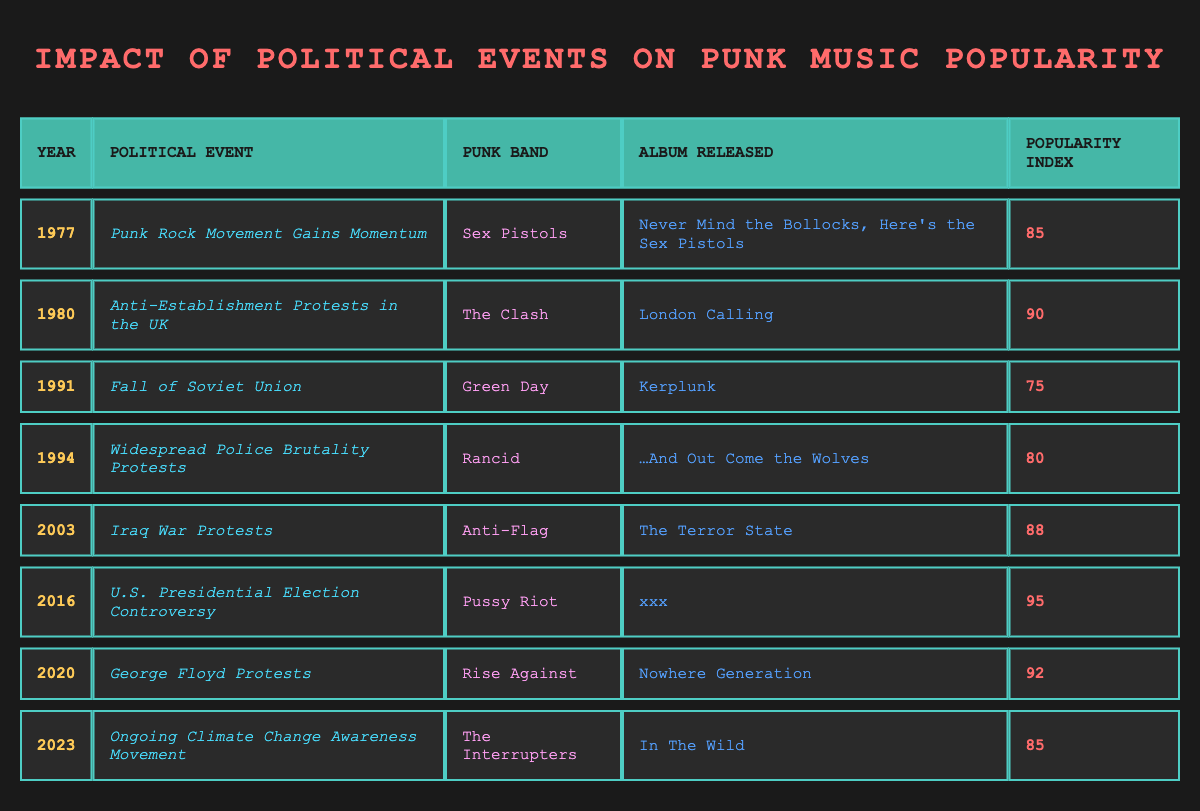What was the popularity index of The Clash's album released in 1980? The Clash released their album "London Calling" in 1980, which has a popularity index of 90 according to the table.
Answer: 90 Which punk band had the highest popularity index and in what year did they release their album? The punk band with the highest popularity index is Pussy Riot, who released the album "xxx" in 2016 with a popularity index of 95.
Answer: Pussy Riot, 2016 Between which years did the popularity index increase from one album to the next? From 2003 to 2016, the popularity index increased from 88 (Anti-Flag’s "The Terror State") to 95 (Pussy Riot’s "xxx"). This indicates a rise over those years.
Answer: 2003 to 2016 Was there any year where the popularity index fell below 80? Yes, the year 1991 shows a popularity index of 75, which is below 80.
Answer: Yes What is the average popularity index of the punk bands between the years 1990 and 2020? The popularity indices for the given years are 75 (1991) + 80 (1994) + 88 (2003) + 95 (2016) + 92 (2020) = 430. There are 5 data points; 430 / 5 = 86.
Answer: 86 Which political event occurred in 1994? The political event that occurred in 1994 was "Widespread Police Brutality Protests," which coincided with Rancid's album release of "…And Out Come the Wolves."
Answer: Widespread Police Brutality Protests How many punk bands released albums that had a popularity index of 85 or higher from 2000 to 2023? From 2000 to 2023, three punk bands released albums with a popularity index of 85 or higher: Anti-Flag (2003, 88), Pussy Riot (2016, 95), and Rise Against (2020, 92), totaling three bands.
Answer: 3 What was the popularity index of the album released in 2023 by The Interrupters? The Interrupters released their album "In The Wild" in 2023, which has a popularity index of 85 as shown in the table.
Answer: 85 